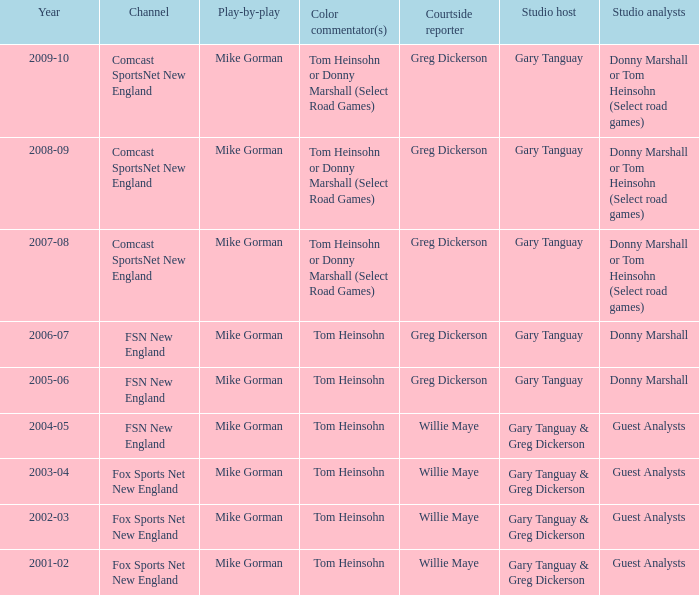Who is the courtside reporter for the year 2009-10? Greg Dickerson. 